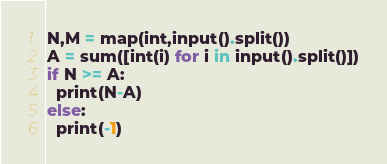Convert code to text. <code><loc_0><loc_0><loc_500><loc_500><_Python_>N,M = map(int,input().split())
A = sum([int(i) for i in input().split()])
if N >= A:
  print(N-A)
else:
  print(-1)</code> 